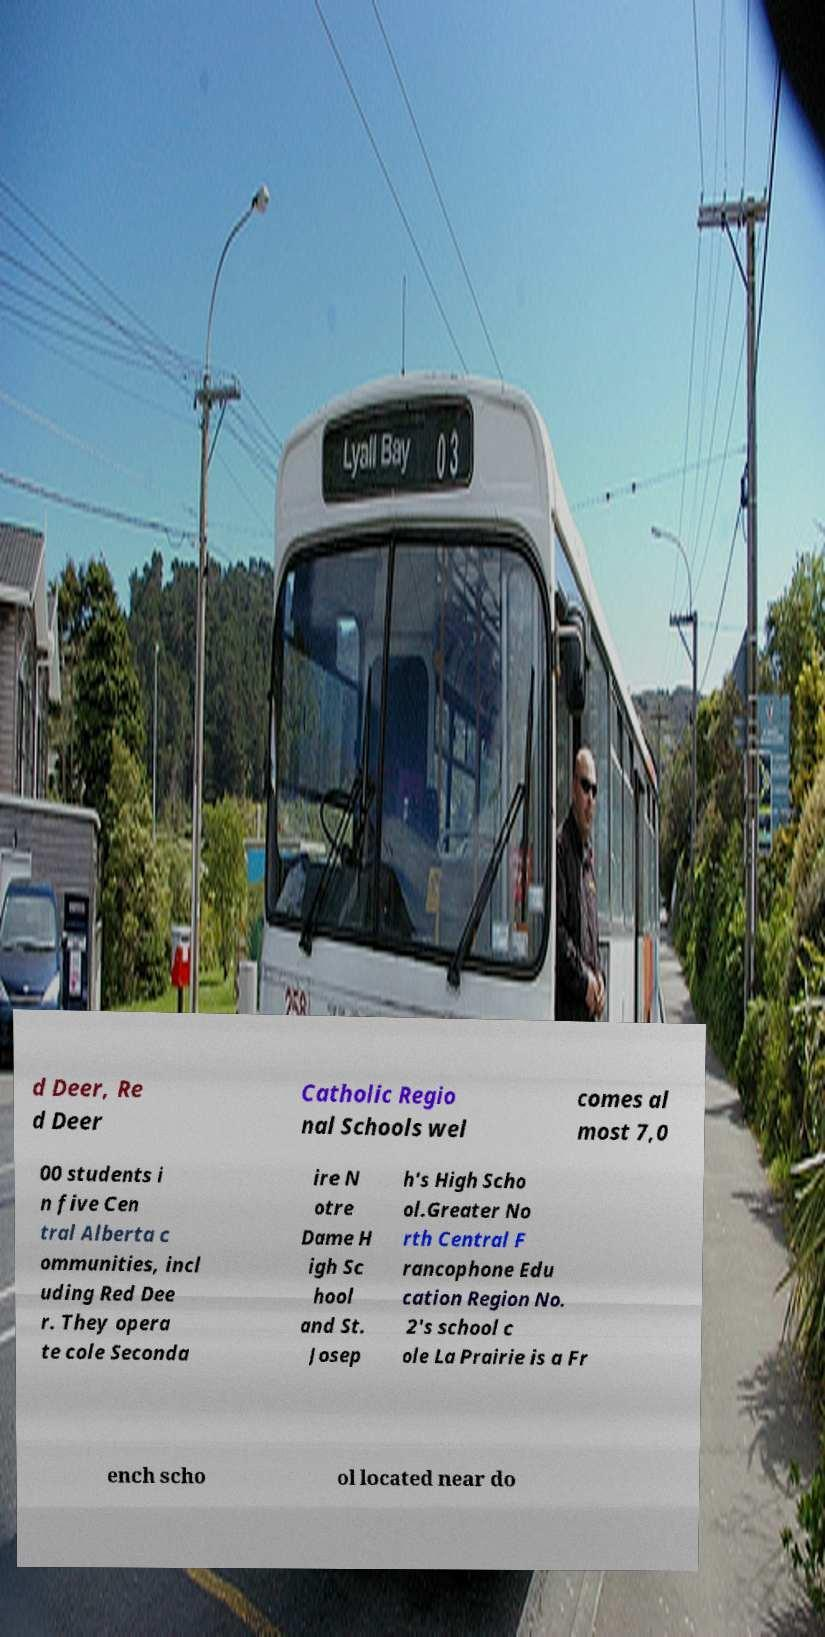Can you accurately transcribe the text from the provided image for me? d Deer, Re d Deer Catholic Regio nal Schools wel comes al most 7,0 00 students i n five Cen tral Alberta c ommunities, incl uding Red Dee r. They opera te cole Seconda ire N otre Dame H igh Sc hool and St. Josep h's High Scho ol.Greater No rth Central F rancophone Edu cation Region No. 2's school c ole La Prairie is a Fr ench scho ol located near do 